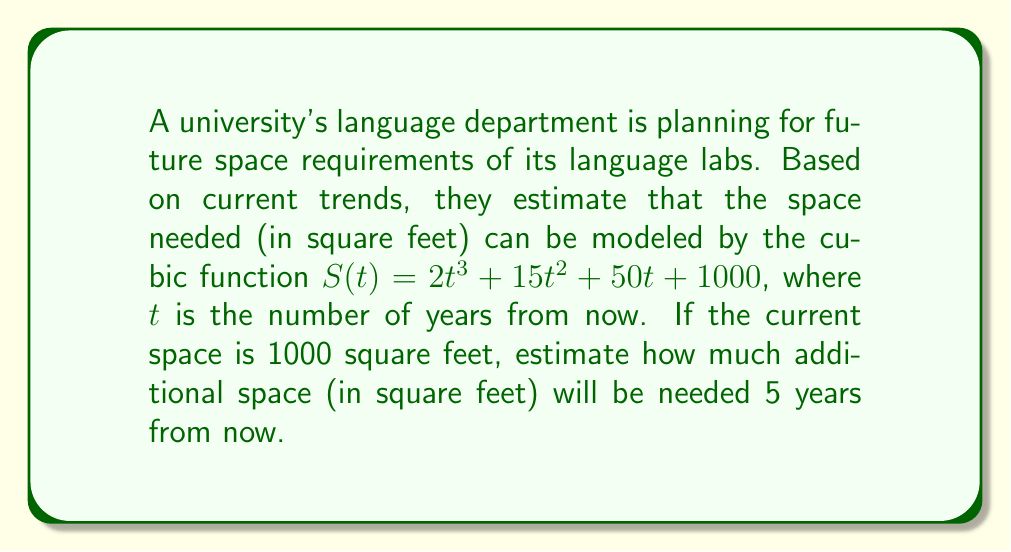What is the answer to this math problem? To solve this problem, we need to follow these steps:

1) The current space is given as 1000 square feet, which corresponds to $t = 0$ in our function.

2) To find the space needed 5 years from now, we need to calculate $S(5)$:

   $$S(5) = 2(5)^3 + 15(5)^2 + 50(5) + 1000$$

3) Let's calculate each term:
   - $2(5)^3 = 2(125) = 250$
   - $15(5)^2 = 15(25) = 375$
   - $50(5) = 250$
   - The constant term is 1000

4) Now, sum up all these terms:

   $$S(5) = 250 + 375 + 250 + 1000 = 1875$$

5) The question asks for additional space needed. To find this, we need to subtract the current space from the space needed in 5 years:

   $$\text{Additional Space} = S(5) - S(0) = 1875 - 1000 = 875$$

Therefore, an additional 875 square feet will be needed 5 years from now.
Answer: 875 square feet 